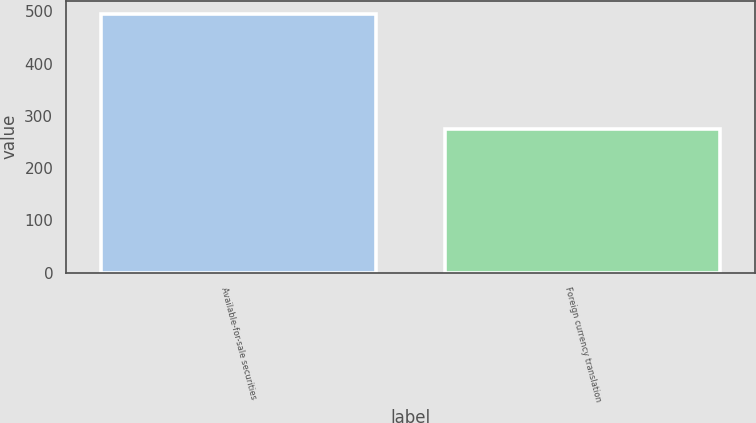Convert chart to OTSL. <chart><loc_0><loc_0><loc_500><loc_500><bar_chart><fcel>Available-for-sale securities<fcel>Foreign currency translation<nl><fcel>495<fcel>275<nl></chart> 